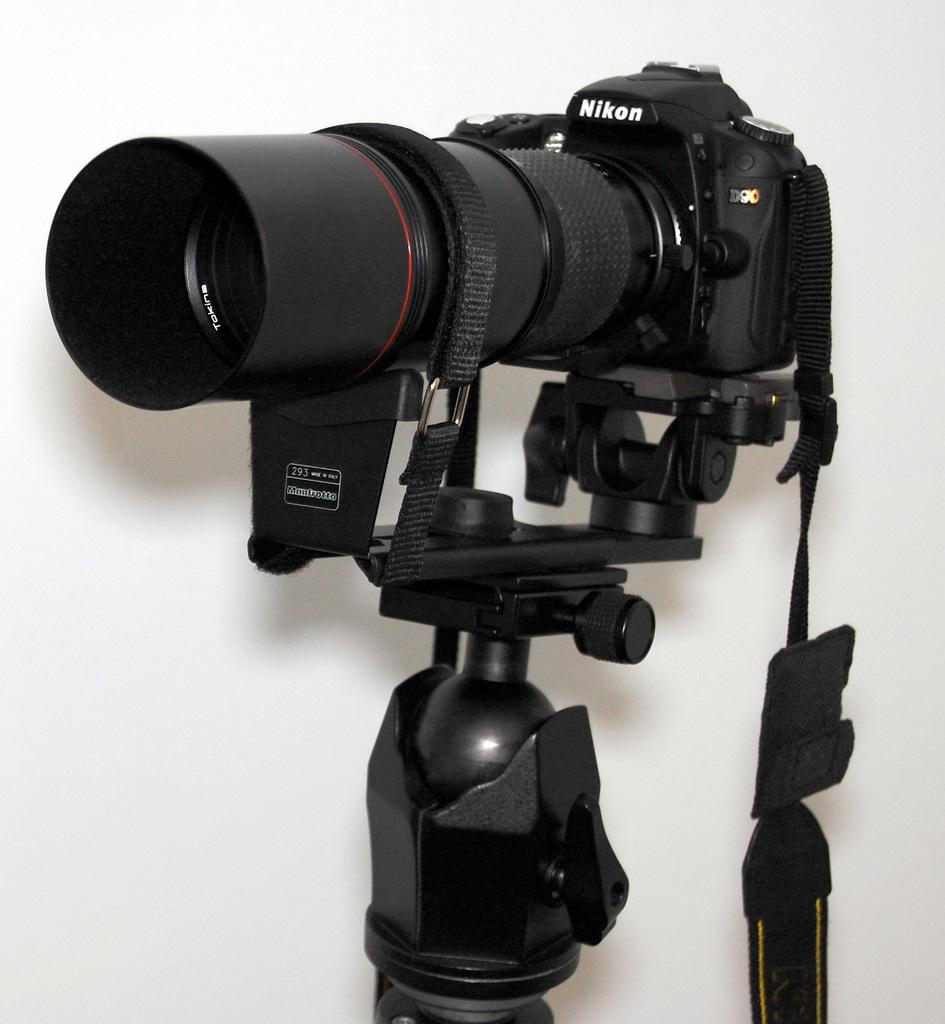What type of camera is in the image? There is a Nikon camera in the image. What color is the Nikon camera? The Nikon camera is black in color. How is the Nikon camera positioned in the image? The Nikon camera is on a camera stand. What type of pipe can be seen connected to the Nikon camera in the image? There is no pipe connected to the Nikon camera in the image. 